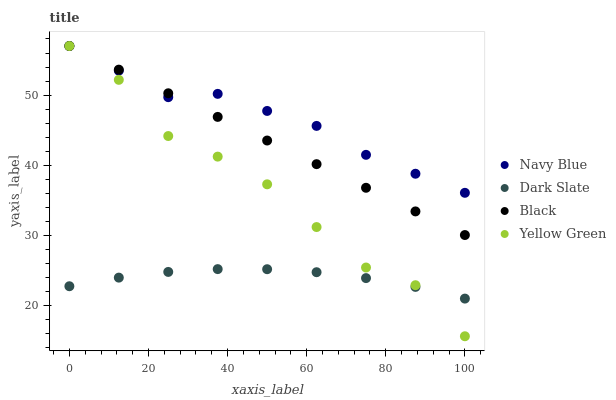Does Dark Slate have the minimum area under the curve?
Answer yes or no. Yes. Does Navy Blue have the maximum area under the curve?
Answer yes or no. Yes. Does Black have the minimum area under the curve?
Answer yes or no. No. Does Black have the maximum area under the curve?
Answer yes or no. No. Is Black the smoothest?
Answer yes or no. Yes. Is Yellow Green the roughest?
Answer yes or no. Yes. Is Yellow Green the smoothest?
Answer yes or no. No. Is Black the roughest?
Answer yes or no. No. Does Yellow Green have the lowest value?
Answer yes or no. Yes. Does Black have the lowest value?
Answer yes or no. No. Does Yellow Green have the highest value?
Answer yes or no. Yes. Does Dark Slate have the highest value?
Answer yes or no. No. Is Dark Slate less than Navy Blue?
Answer yes or no. Yes. Is Black greater than Dark Slate?
Answer yes or no. Yes. Does Navy Blue intersect Yellow Green?
Answer yes or no. Yes. Is Navy Blue less than Yellow Green?
Answer yes or no. No. Is Navy Blue greater than Yellow Green?
Answer yes or no. No. Does Dark Slate intersect Navy Blue?
Answer yes or no. No. 